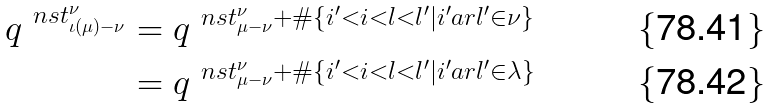Convert formula to latex. <formula><loc_0><loc_0><loc_500><loc_500>q ^ { \ n s t _ { \iota ( \mu ) - \nu } ^ { \nu } } & = q ^ { \ n s t _ { \mu - \nu } ^ { \nu } + \# \{ i ^ { \prime } < i < l < l ^ { \prime } | i ^ { \prime } \sl a r l ^ { \prime } \in \nu \} } \\ & = q ^ { \ n s t _ { \mu - \nu } ^ { \nu } + \# \{ i ^ { \prime } < i < l < l ^ { \prime } | i ^ { \prime } \sl a r l ^ { \prime } \in \lambda \} }</formula> 